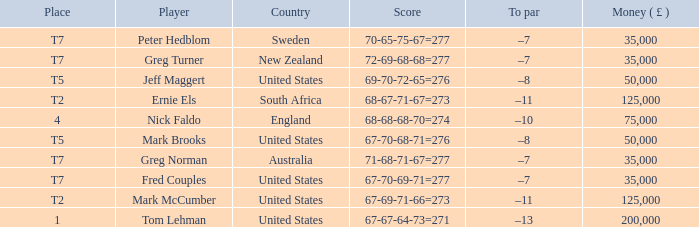What is To par, when Country is "United States", when Money ( £ ) is greater than 125,000, and when Score is "67-70-68-71=276"? None. I'm looking to parse the entire table for insights. Could you assist me with that? {'header': ['Place', 'Player', 'Country', 'Score', 'To par', 'Money ( £ )'], 'rows': [['T7', 'Peter Hedblom', 'Sweden', '70-65-75-67=277', '–7', '35,000'], ['T7', 'Greg Turner', 'New Zealand', '72-69-68-68=277', '–7', '35,000'], ['T5', 'Jeff Maggert', 'United States', '69-70-72-65=276', '–8', '50,000'], ['T2', 'Ernie Els', 'South Africa', '68-67-71-67=273', '–11', '125,000'], ['4', 'Nick Faldo', 'England', '68-68-68-70=274', '–10', '75,000'], ['T5', 'Mark Brooks', 'United States', '67-70-68-71=276', '–8', '50,000'], ['T7', 'Greg Norman', 'Australia', '71-68-71-67=277', '–7', '35,000'], ['T7', 'Fred Couples', 'United States', '67-70-69-71=277', '–7', '35,000'], ['T2', 'Mark McCumber', 'United States', '67-69-71-66=273', '–11', '125,000'], ['1', 'Tom Lehman', 'United States', '67-67-64-73=271', '–13', '200,000']]} 